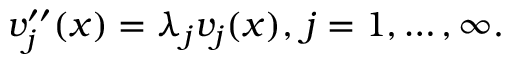Convert formula to latex. <formula><loc_0><loc_0><loc_500><loc_500>v _ { j } ^ { \prime \prime } ( x ) = \lambda _ { j } v _ { j } ( x ) , \, j = 1 , \dots , \infty .</formula> 